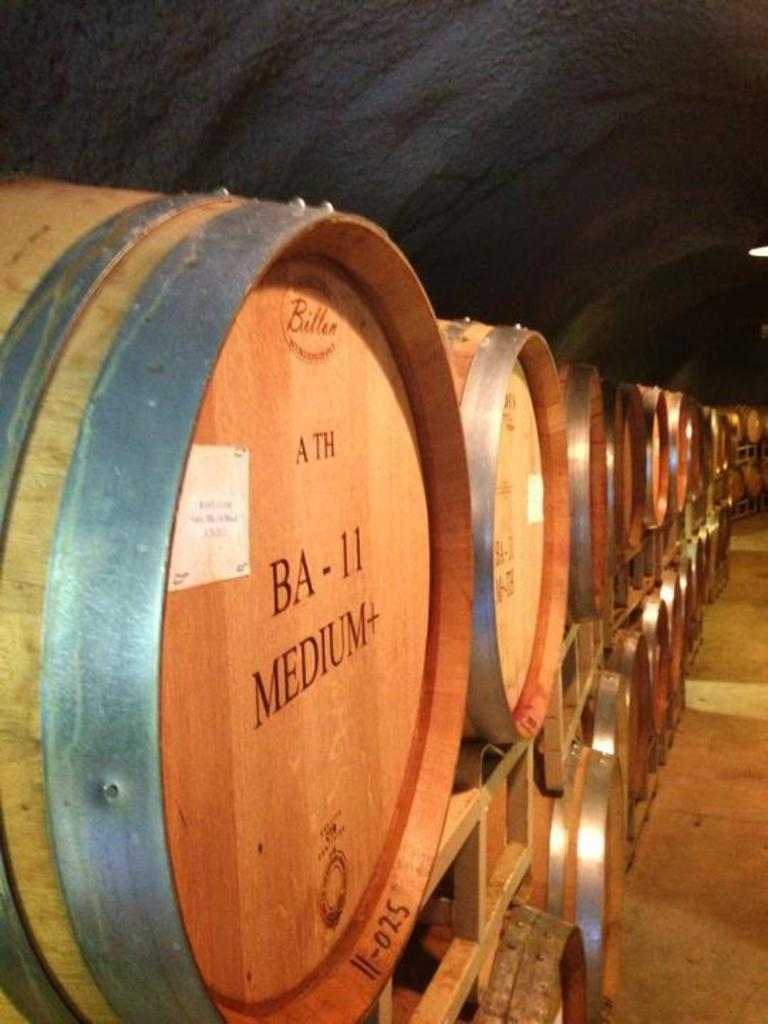What objects are present in the image? There are barrels in the image. Where are the barrels located? The barrels are in a tunnel. What type of jelly can be seen on the walls of the tunnel in the image? There is no jelly present in the image; it features barrels in a tunnel. 